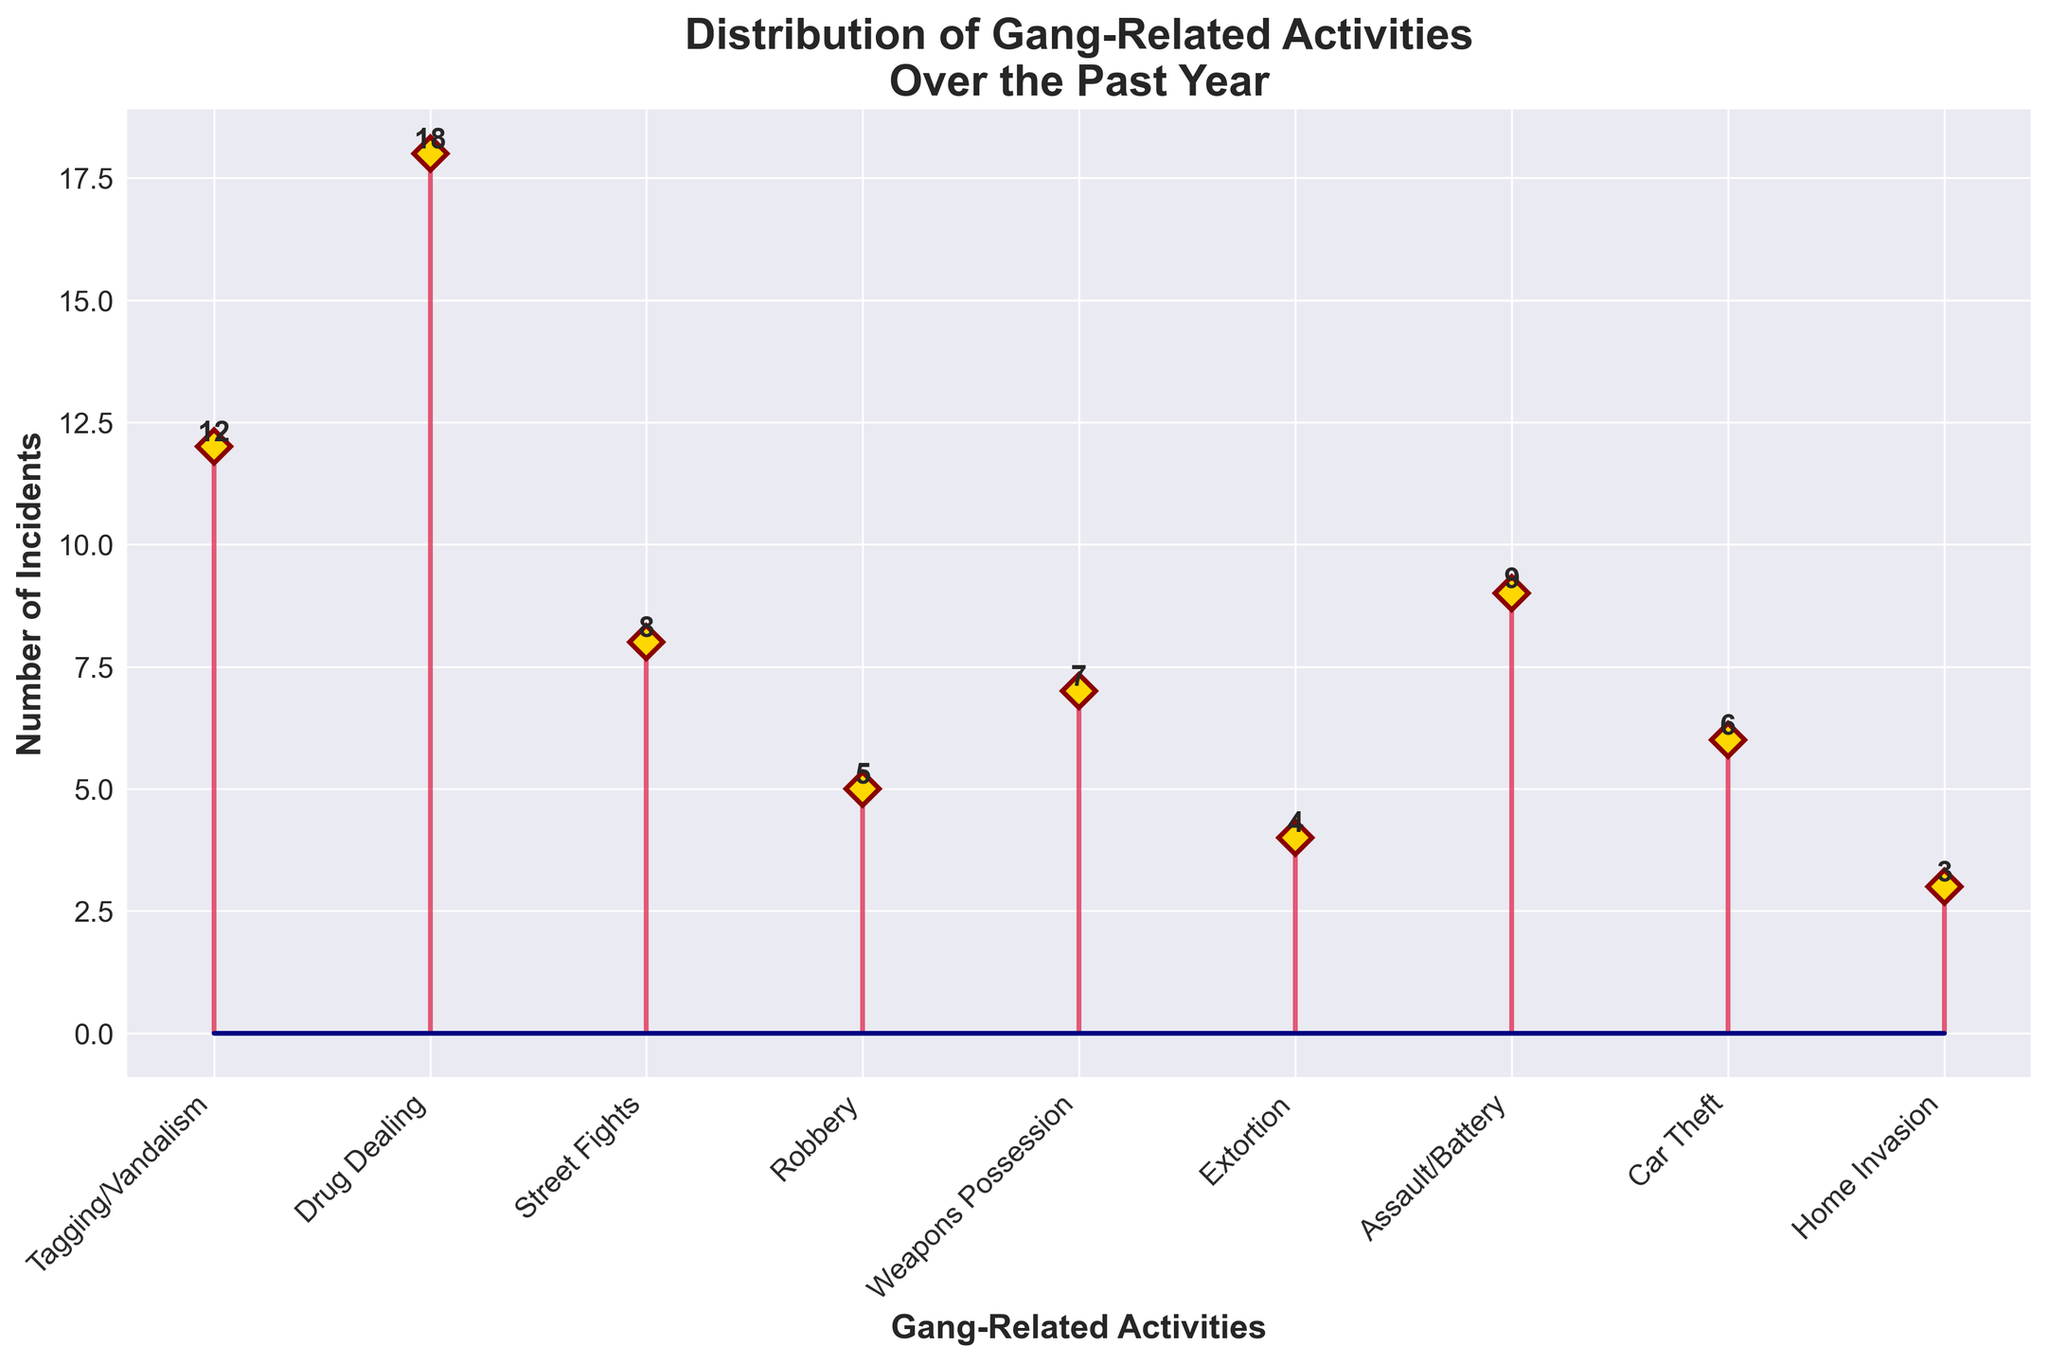What's the title of the plot? The title is presented at the top of the plot and generally summarises the information being shown.
Answer: Distribution of Gang-Related Activities Over the Past Year Which activity has the highest number of incidents? By observing the height of the markers, you can determine which activity has the highest count.
Answer: Drug Dealing How many incidents of Car Theft were reported? The text annotation or the position of the data point representing Car Theft provides this information.
Answer: 6 What is the total number of incidents reported? Sum up all the occurrences of each activity: 12 + 18 + 8 + 5 + 7 + 4 + 9 + 6 + 3 = 72
Answer: 72 Which activities have more incidents than Assault/Battery? Identify and compare the counts of each activity; those greater than 9 (Assault/Battery) are the answers.
Answer: Tagging/Vandalism, Drug Dealing What is the average number of incidents per activity? Divide the total number of incidents by the number of different activities. 72 / 9 = 8
Answer: 8 How many more incidents of Drug Dealing are there compared to Robbery? Subtract the count of Robbery from the count of Drug Dealing. 18 - 5 = 13
Answer: 13 What’s the second most frequent type of gang-related activity? After identifying the activity with the highest count, find the next highest count and correlate it to the corresponding activity.
Answer: Tagging/Vandalism What is the median number of incidents among all the activities? Arrange the counts in ascending order and find the middle number. Sorted counts: 3, 4, 5, 6, 7, 8, 9, 12, 18; the middle one is 7
Answer: 7 Which activities have less than 5 incidents reported? Identify the activities with counts less than 5 by comparing each count with 5.
Answer: Home Invasion, Extortion 